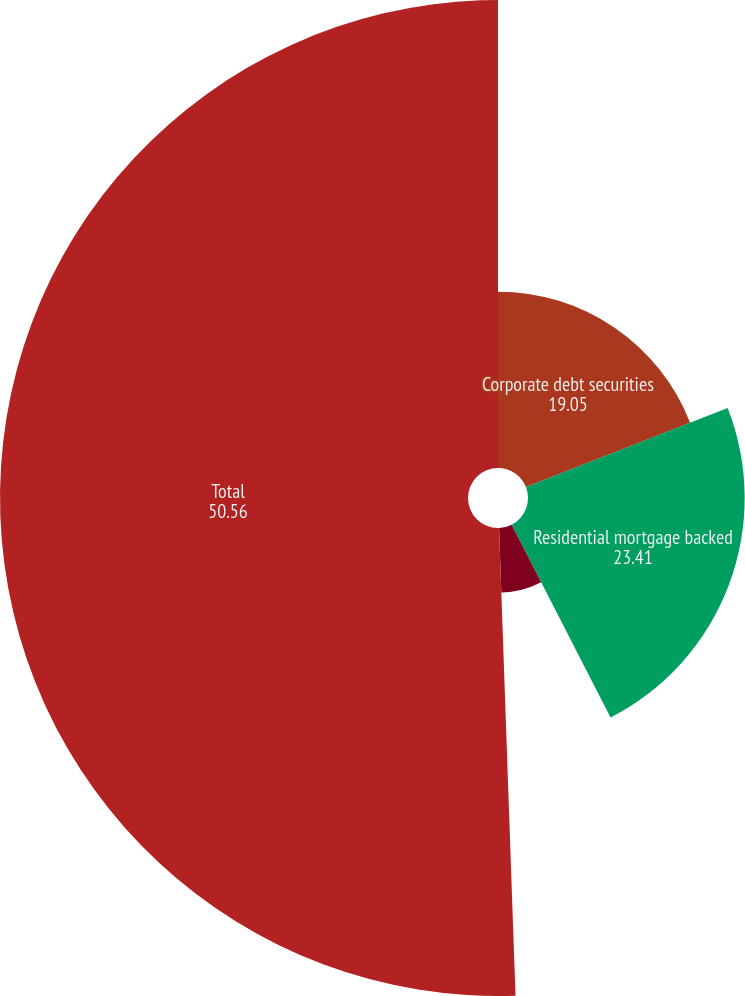Convert chart. <chart><loc_0><loc_0><loc_500><loc_500><pie_chart><fcel>Corporate debt securities<fcel>Residential mortgage backed<fcel>Asset backed securities<fcel>Total<nl><fcel>19.05%<fcel>23.41%<fcel>6.98%<fcel>50.56%<nl></chart> 